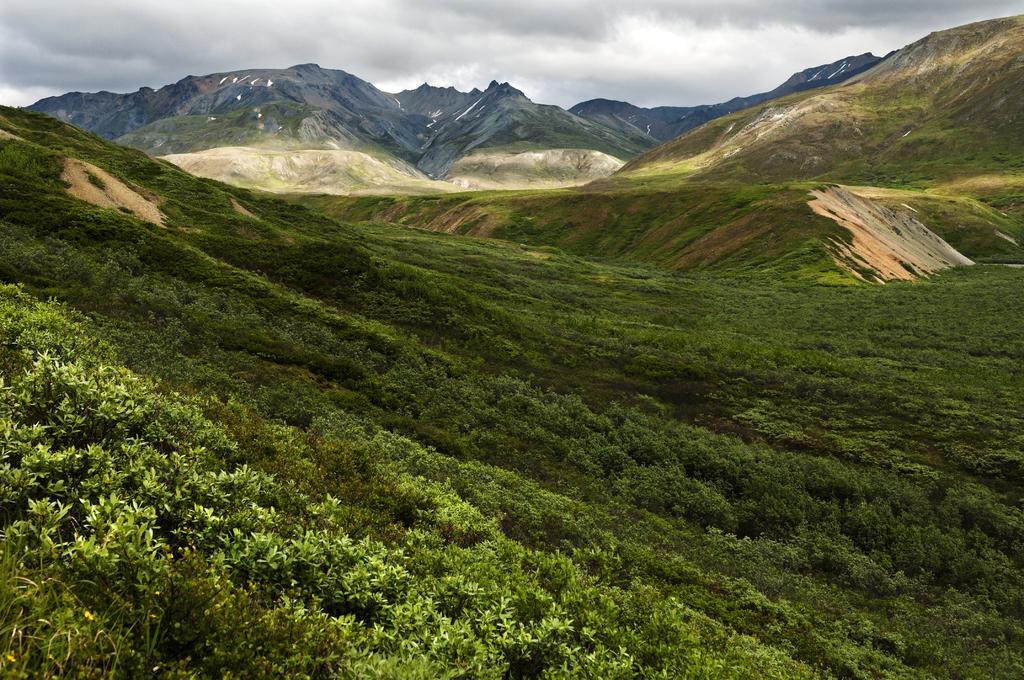Please provide a concise description of this image. In this image we can see plants, grass, and mountains. In the background there is sky with clouds. 